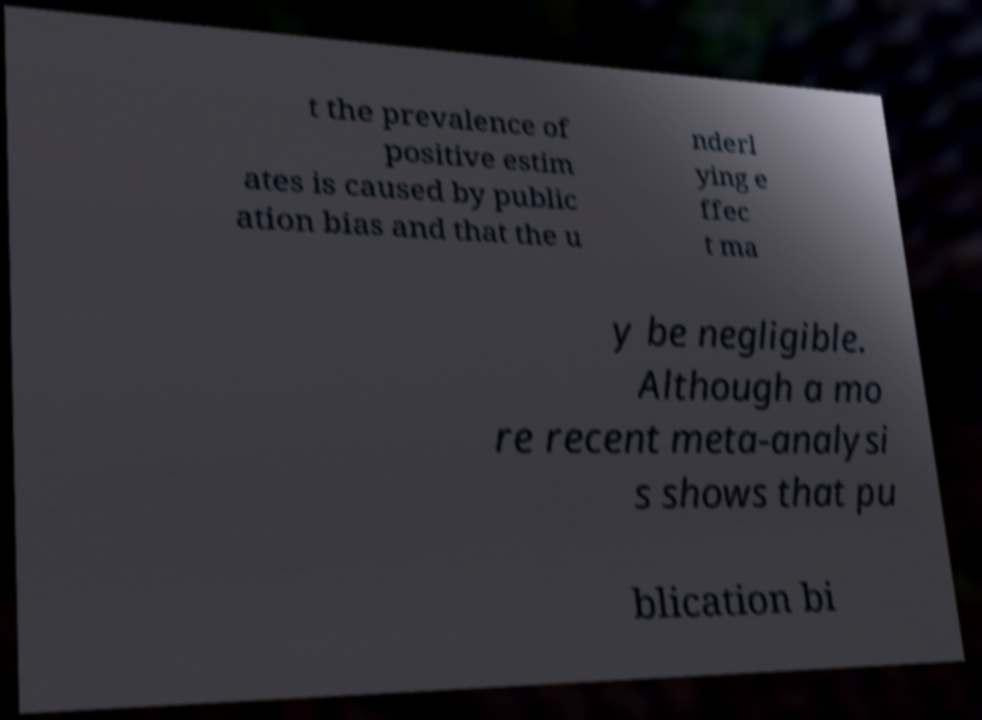There's text embedded in this image that I need extracted. Can you transcribe it verbatim? t the prevalence of positive estim ates is caused by public ation bias and that the u nderl ying e ffec t ma y be negligible. Although a mo re recent meta-analysi s shows that pu blication bi 